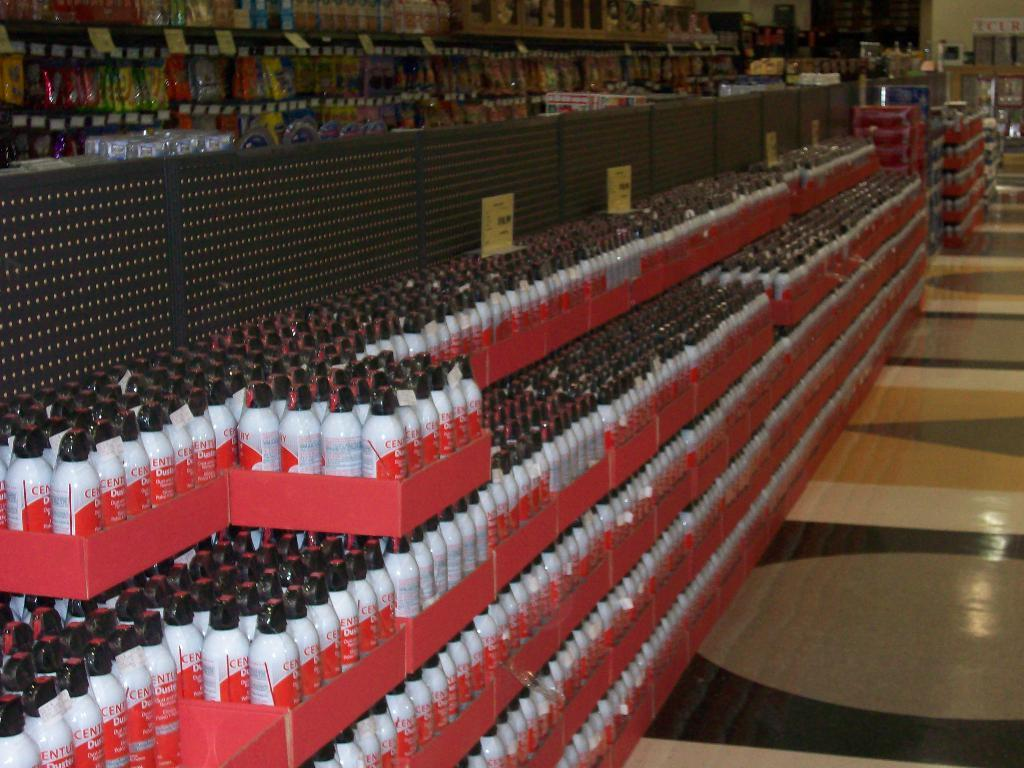What type of location is depicted in the image? The image is set in a supermarket space. What objects can be seen on the floor in the image? There are glass bottles on the floor. Can you see a comb being used by a goat in the supermarket space? No, there is no goat or comb present in the image. 